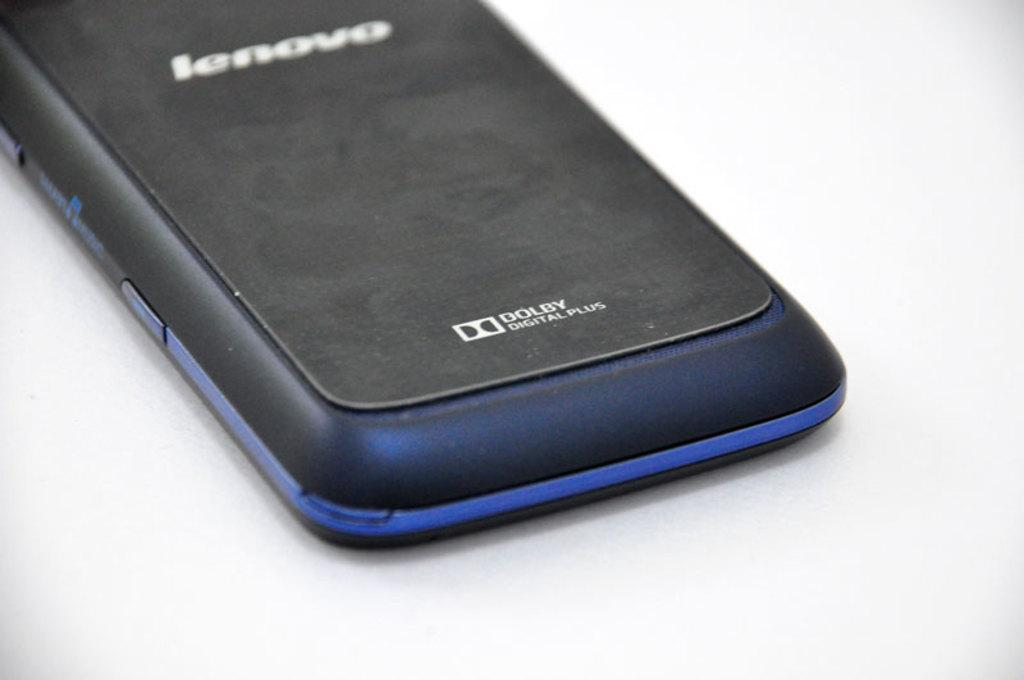<image>
Describe the image concisely. a the back of a lenovo dolby digital plus cell phone 